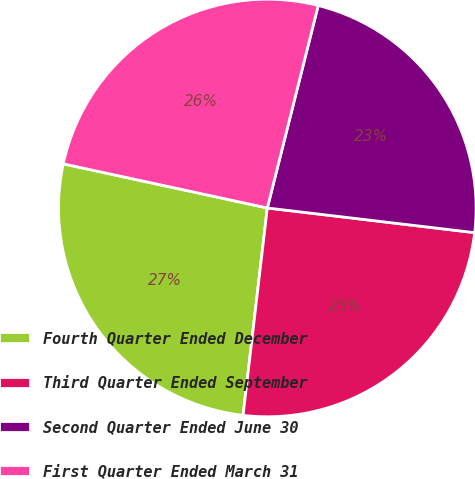Convert chart. <chart><loc_0><loc_0><loc_500><loc_500><pie_chart><fcel>Fourth Quarter Ended December<fcel>Third Quarter Ended September<fcel>Second Quarter Ended June 30<fcel>First Quarter Ended March 31<nl><fcel>26.54%<fcel>24.97%<fcel>22.97%<fcel>25.53%<nl></chart> 